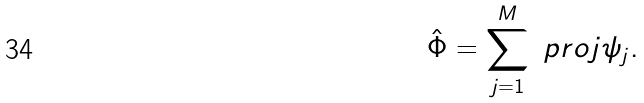Convert formula to latex. <formula><loc_0><loc_0><loc_500><loc_500>\hat { \Phi } = \sum _ { j = 1 } ^ { M } \ p r o j { \psi _ { j } } .</formula> 